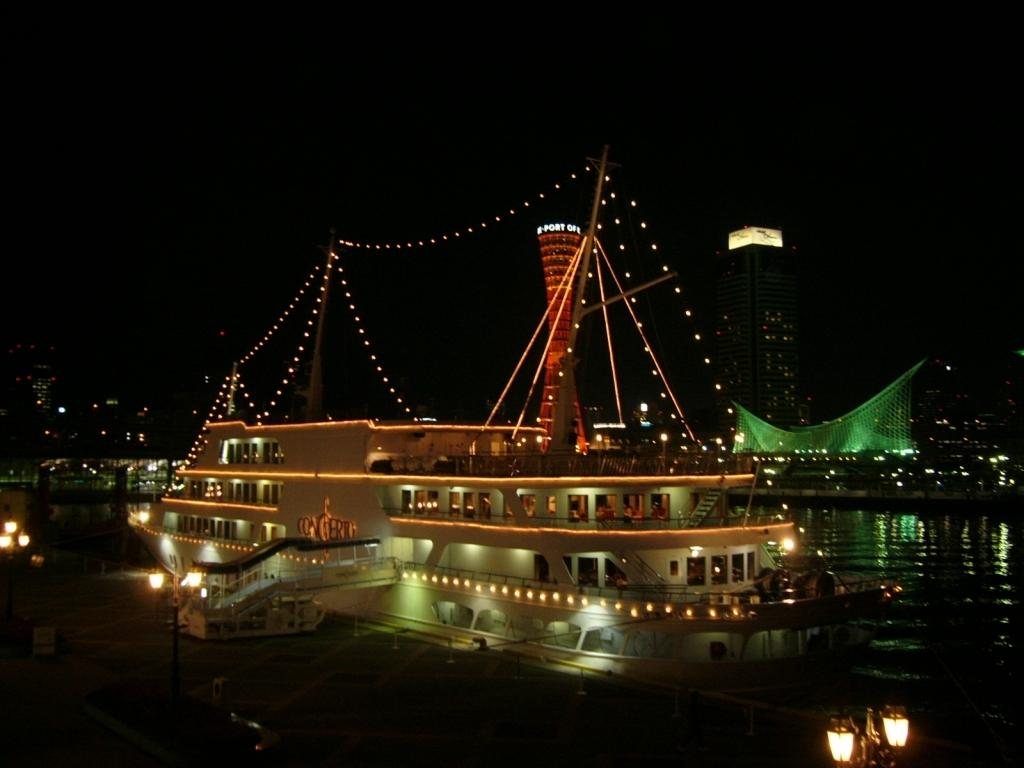What is the main subject in the water in the image? There is a ship in the water in the image. What feature of the ship can be observed? The ship has lights. What type of water feature is present in the image? There is a pool in the image. What type of artificial light source is visible in the image? There are street lights in the image. What type of man-made structures are visible in the image? There are buildings in the image. What type of garden can be seen near the ship in the image? There is no garden visible near the ship in the image. Can you tell me how many toads are sitting on the ship in the image? There are no toads present on the ship in the image. 